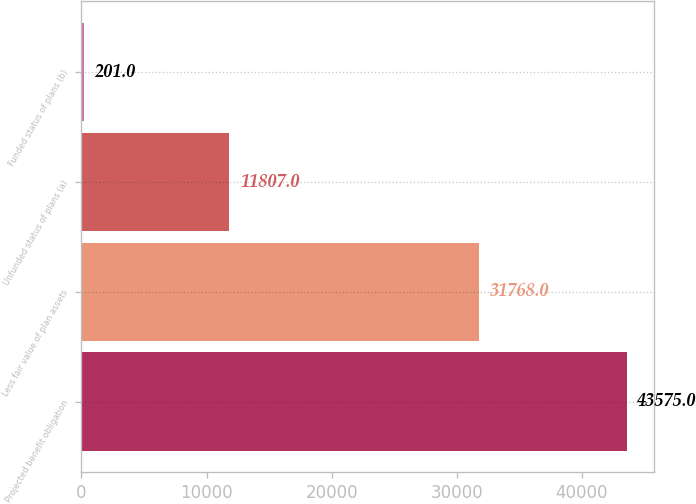Convert chart. <chart><loc_0><loc_0><loc_500><loc_500><bar_chart><fcel>Projected benefit obligation<fcel>Less fair value of plan assets<fcel>Unfunded status of plans (a)<fcel>Funded status of plans (b)<nl><fcel>43575<fcel>31768<fcel>11807<fcel>201<nl></chart> 